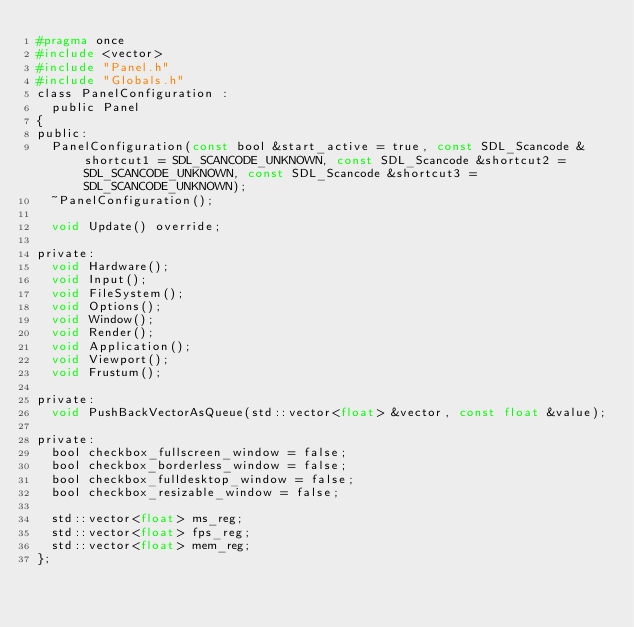Convert code to text. <code><loc_0><loc_0><loc_500><loc_500><_C_>#pragma once
#include <vector>
#include "Panel.h"
#include "Globals.h"
class PanelConfiguration :
	public Panel
{
public:
	PanelConfiguration(const bool &start_active = true, const SDL_Scancode &shortcut1 = SDL_SCANCODE_UNKNOWN, const SDL_Scancode &shortcut2 = SDL_SCANCODE_UNKNOWN, const SDL_Scancode &shortcut3 = SDL_SCANCODE_UNKNOWN);
	~PanelConfiguration();

	void Update() override;

private:
	void Hardware();
	void Input();
	void FileSystem();
	void Options();
	void Window();
	void Render();
	void Application();
	void Viewport();
	void Frustum();

private:
	void PushBackVectorAsQueue(std::vector<float> &vector, const float &value);

private:
	bool checkbox_fullscreen_window = false;
	bool checkbox_borderless_window = false;
	bool checkbox_fulldesktop_window = false;
	bool checkbox_resizable_window = false;

	std::vector<float> ms_reg;
	std::vector<float> fps_reg;
	std::vector<float> mem_reg;
};

</code> 